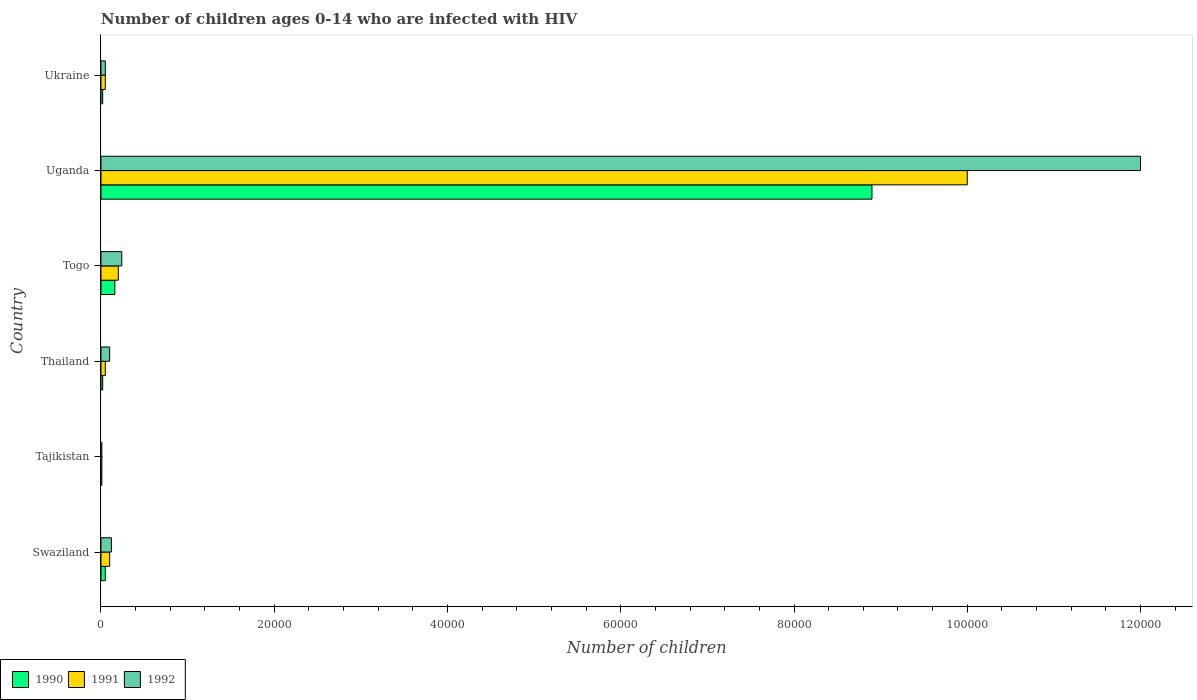How many different coloured bars are there?
Keep it short and to the point. 3. How many bars are there on the 1st tick from the top?
Provide a short and direct response. 3. How many bars are there on the 2nd tick from the bottom?
Provide a succinct answer. 3. What is the label of the 4th group of bars from the top?
Your answer should be compact. Thailand. What is the number of HIV infected children in 1991 in Thailand?
Keep it short and to the point. 500. Across all countries, what is the maximum number of HIV infected children in 1992?
Keep it short and to the point. 1.20e+05. Across all countries, what is the minimum number of HIV infected children in 1991?
Offer a very short reply. 100. In which country was the number of HIV infected children in 1990 maximum?
Make the answer very short. Uganda. In which country was the number of HIV infected children in 1991 minimum?
Provide a short and direct response. Tajikistan. What is the total number of HIV infected children in 1990 in the graph?
Your answer should be very brief. 9.16e+04. What is the difference between the number of HIV infected children in 1991 in Tajikistan and that in Thailand?
Your answer should be compact. -400. What is the difference between the number of HIV infected children in 1990 in Togo and the number of HIV infected children in 1991 in Swaziland?
Ensure brevity in your answer.  600. What is the average number of HIV infected children in 1991 per country?
Your answer should be compact. 1.74e+04. What is the difference between the number of HIV infected children in 1992 and number of HIV infected children in 1991 in Togo?
Provide a succinct answer. 400. In how many countries, is the number of HIV infected children in 1991 greater than 20000 ?
Offer a very short reply. 1. Is the number of HIV infected children in 1991 in Tajikistan less than that in Ukraine?
Provide a succinct answer. Yes. What is the difference between the highest and the second highest number of HIV infected children in 1992?
Offer a very short reply. 1.18e+05. What is the difference between the highest and the lowest number of HIV infected children in 1992?
Offer a very short reply. 1.20e+05. What does the 3rd bar from the top in Tajikistan represents?
Offer a very short reply. 1990. What does the 3rd bar from the bottom in Togo represents?
Your answer should be compact. 1992. How many bars are there?
Offer a terse response. 18. Are all the bars in the graph horizontal?
Offer a terse response. Yes. Does the graph contain any zero values?
Provide a succinct answer. No. Where does the legend appear in the graph?
Your answer should be very brief. Bottom left. How are the legend labels stacked?
Your response must be concise. Horizontal. What is the title of the graph?
Provide a succinct answer. Number of children ages 0-14 who are infected with HIV. What is the label or title of the X-axis?
Make the answer very short. Number of children. What is the Number of children of 1991 in Swaziland?
Your answer should be compact. 1000. What is the Number of children in 1992 in Swaziland?
Provide a succinct answer. 1200. What is the Number of children in 1990 in Tajikistan?
Your answer should be compact. 100. What is the Number of children of 1991 in Tajikistan?
Provide a succinct answer. 100. What is the Number of children of 1992 in Tajikistan?
Ensure brevity in your answer.  100. What is the Number of children of 1990 in Thailand?
Provide a short and direct response. 200. What is the Number of children of 1992 in Thailand?
Offer a very short reply. 1000. What is the Number of children of 1990 in Togo?
Your answer should be very brief. 1600. What is the Number of children of 1992 in Togo?
Make the answer very short. 2400. What is the Number of children of 1990 in Uganda?
Provide a succinct answer. 8.90e+04. What is the Number of children of 1990 in Ukraine?
Your answer should be very brief. 200. Across all countries, what is the maximum Number of children of 1990?
Your response must be concise. 8.90e+04. Across all countries, what is the minimum Number of children in 1990?
Offer a terse response. 100. Across all countries, what is the minimum Number of children of 1991?
Keep it short and to the point. 100. Across all countries, what is the minimum Number of children of 1992?
Ensure brevity in your answer.  100. What is the total Number of children in 1990 in the graph?
Ensure brevity in your answer.  9.16e+04. What is the total Number of children in 1991 in the graph?
Your answer should be compact. 1.04e+05. What is the total Number of children in 1992 in the graph?
Offer a very short reply. 1.25e+05. What is the difference between the Number of children of 1991 in Swaziland and that in Tajikistan?
Make the answer very short. 900. What is the difference between the Number of children of 1992 in Swaziland and that in Tajikistan?
Provide a short and direct response. 1100. What is the difference between the Number of children of 1990 in Swaziland and that in Thailand?
Offer a very short reply. 300. What is the difference between the Number of children in 1990 in Swaziland and that in Togo?
Provide a succinct answer. -1100. What is the difference between the Number of children of 1991 in Swaziland and that in Togo?
Ensure brevity in your answer.  -1000. What is the difference between the Number of children of 1992 in Swaziland and that in Togo?
Your answer should be very brief. -1200. What is the difference between the Number of children of 1990 in Swaziland and that in Uganda?
Ensure brevity in your answer.  -8.85e+04. What is the difference between the Number of children of 1991 in Swaziland and that in Uganda?
Offer a terse response. -9.90e+04. What is the difference between the Number of children of 1992 in Swaziland and that in Uganda?
Give a very brief answer. -1.19e+05. What is the difference between the Number of children in 1990 in Swaziland and that in Ukraine?
Your answer should be very brief. 300. What is the difference between the Number of children of 1991 in Swaziland and that in Ukraine?
Provide a succinct answer. 500. What is the difference between the Number of children of 1992 in Swaziland and that in Ukraine?
Provide a succinct answer. 700. What is the difference between the Number of children in 1990 in Tajikistan and that in Thailand?
Your answer should be compact. -100. What is the difference between the Number of children in 1991 in Tajikistan and that in Thailand?
Offer a very short reply. -400. What is the difference between the Number of children of 1992 in Tajikistan and that in Thailand?
Make the answer very short. -900. What is the difference between the Number of children of 1990 in Tajikistan and that in Togo?
Provide a short and direct response. -1500. What is the difference between the Number of children in 1991 in Tajikistan and that in Togo?
Provide a succinct answer. -1900. What is the difference between the Number of children in 1992 in Tajikistan and that in Togo?
Provide a short and direct response. -2300. What is the difference between the Number of children in 1990 in Tajikistan and that in Uganda?
Keep it short and to the point. -8.89e+04. What is the difference between the Number of children in 1991 in Tajikistan and that in Uganda?
Keep it short and to the point. -9.99e+04. What is the difference between the Number of children in 1992 in Tajikistan and that in Uganda?
Your response must be concise. -1.20e+05. What is the difference between the Number of children of 1990 in Tajikistan and that in Ukraine?
Your answer should be compact. -100. What is the difference between the Number of children in 1991 in Tajikistan and that in Ukraine?
Your response must be concise. -400. What is the difference between the Number of children of 1992 in Tajikistan and that in Ukraine?
Offer a terse response. -400. What is the difference between the Number of children in 1990 in Thailand and that in Togo?
Your response must be concise. -1400. What is the difference between the Number of children in 1991 in Thailand and that in Togo?
Offer a very short reply. -1500. What is the difference between the Number of children in 1992 in Thailand and that in Togo?
Ensure brevity in your answer.  -1400. What is the difference between the Number of children of 1990 in Thailand and that in Uganda?
Ensure brevity in your answer.  -8.88e+04. What is the difference between the Number of children in 1991 in Thailand and that in Uganda?
Make the answer very short. -9.95e+04. What is the difference between the Number of children in 1992 in Thailand and that in Uganda?
Your response must be concise. -1.19e+05. What is the difference between the Number of children in 1992 in Thailand and that in Ukraine?
Keep it short and to the point. 500. What is the difference between the Number of children in 1990 in Togo and that in Uganda?
Provide a succinct answer. -8.74e+04. What is the difference between the Number of children in 1991 in Togo and that in Uganda?
Keep it short and to the point. -9.80e+04. What is the difference between the Number of children in 1992 in Togo and that in Uganda?
Ensure brevity in your answer.  -1.18e+05. What is the difference between the Number of children in 1990 in Togo and that in Ukraine?
Offer a very short reply. 1400. What is the difference between the Number of children in 1991 in Togo and that in Ukraine?
Your response must be concise. 1500. What is the difference between the Number of children in 1992 in Togo and that in Ukraine?
Provide a succinct answer. 1900. What is the difference between the Number of children of 1990 in Uganda and that in Ukraine?
Give a very brief answer. 8.88e+04. What is the difference between the Number of children in 1991 in Uganda and that in Ukraine?
Your answer should be very brief. 9.95e+04. What is the difference between the Number of children in 1992 in Uganda and that in Ukraine?
Make the answer very short. 1.20e+05. What is the difference between the Number of children of 1991 in Swaziland and the Number of children of 1992 in Tajikistan?
Ensure brevity in your answer.  900. What is the difference between the Number of children of 1990 in Swaziland and the Number of children of 1991 in Thailand?
Offer a very short reply. 0. What is the difference between the Number of children of 1990 in Swaziland and the Number of children of 1992 in Thailand?
Provide a short and direct response. -500. What is the difference between the Number of children in 1991 in Swaziland and the Number of children in 1992 in Thailand?
Ensure brevity in your answer.  0. What is the difference between the Number of children in 1990 in Swaziland and the Number of children in 1991 in Togo?
Provide a succinct answer. -1500. What is the difference between the Number of children of 1990 in Swaziland and the Number of children of 1992 in Togo?
Keep it short and to the point. -1900. What is the difference between the Number of children of 1991 in Swaziland and the Number of children of 1992 in Togo?
Your answer should be compact. -1400. What is the difference between the Number of children in 1990 in Swaziland and the Number of children in 1991 in Uganda?
Give a very brief answer. -9.95e+04. What is the difference between the Number of children of 1990 in Swaziland and the Number of children of 1992 in Uganda?
Make the answer very short. -1.20e+05. What is the difference between the Number of children in 1991 in Swaziland and the Number of children in 1992 in Uganda?
Offer a very short reply. -1.19e+05. What is the difference between the Number of children of 1991 in Swaziland and the Number of children of 1992 in Ukraine?
Your answer should be very brief. 500. What is the difference between the Number of children in 1990 in Tajikistan and the Number of children in 1991 in Thailand?
Your answer should be very brief. -400. What is the difference between the Number of children in 1990 in Tajikistan and the Number of children in 1992 in Thailand?
Keep it short and to the point. -900. What is the difference between the Number of children in 1991 in Tajikistan and the Number of children in 1992 in Thailand?
Offer a very short reply. -900. What is the difference between the Number of children of 1990 in Tajikistan and the Number of children of 1991 in Togo?
Your answer should be compact. -1900. What is the difference between the Number of children of 1990 in Tajikistan and the Number of children of 1992 in Togo?
Ensure brevity in your answer.  -2300. What is the difference between the Number of children in 1991 in Tajikistan and the Number of children in 1992 in Togo?
Offer a terse response. -2300. What is the difference between the Number of children of 1990 in Tajikistan and the Number of children of 1991 in Uganda?
Your response must be concise. -9.99e+04. What is the difference between the Number of children of 1990 in Tajikistan and the Number of children of 1992 in Uganda?
Your answer should be compact. -1.20e+05. What is the difference between the Number of children of 1991 in Tajikistan and the Number of children of 1992 in Uganda?
Provide a short and direct response. -1.20e+05. What is the difference between the Number of children of 1990 in Tajikistan and the Number of children of 1991 in Ukraine?
Your answer should be compact. -400. What is the difference between the Number of children of 1990 in Tajikistan and the Number of children of 1992 in Ukraine?
Your response must be concise. -400. What is the difference between the Number of children in 1991 in Tajikistan and the Number of children in 1992 in Ukraine?
Provide a short and direct response. -400. What is the difference between the Number of children of 1990 in Thailand and the Number of children of 1991 in Togo?
Provide a succinct answer. -1800. What is the difference between the Number of children in 1990 in Thailand and the Number of children in 1992 in Togo?
Offer a terse response. -2200. What is the difference between the Number of children of 1991 in Thailand and the Number of children of 1992 in Togo?
Ensure brevity in your answer.  -1900. What is the difference between the Number of children of 1990 in Thailand and the Number of children of 1991 in Uganda?
Offer a very short reply. -9.98e+04. What is the difference between the Number of children in 1990 in Thailand and the Number of children in 1992 in Uganda?
Your answer should be compact. -1.20e+05. What is the difference between the Number of children in 1991 in Thailand and the Number of children in 1992 in Uganda?
Your answer should be compact. -1.20e+05. What is the difference between the Number of children in 1990 in Thailand and the Number of children in 1991 in Ukraine?
Give a very brief answer. -300. What is the difference between the Number of children of 1990 in Thailand and the Number of children of 1992 in Ukraine?
Your response must be concise. -300. What is the difference between the Number of children of 1990 in Togo and the Number of children of 1991 in Uganda?
Ensure brevity in your answer.  -9.84e+04. What is the difference between the Number of children of 1990 in Togo and the Number of children of 1992 in Uganda?
Provide a succinct answer. -1.18e+05. What is the difference between the Number of children in 1991 in Togo and the Number of children in 1992 in Uganda?
Give a very brief answer. -1.18e+05. What is the difference between the Number of children in 1990 in Togo and the Number of children in 1991 in Ukraine?
Offer a terse response. 1100. What is the difference between the Number of children of 1990 in Togo and the Number of children of 1992 in Ukraine?
Your answer should be compact. 1100. What is the difference between the Number of children of 1991 in Togo and the Number of children of 1992 in Ukraine?
Ensure brevity in your answer.  1500. What is the difference between the Number of children of 1990 in Uganda and the Number of children of 1991 in Ukraine?
Provide a succinct answer. 8.85e+04. What is the difference between the Number of children in 1990 in Uganda and the Number of children in 1992 in Ukraine?
Provide a short and direct response. 8.85e+04. What is the difference between the Number of children of 1991 in Uganda and the Number of children of 1992 in Ukraine?
Provide a succinct answer. 9.95e+04. What is the average Number of children in 1990 per country?
Your answer should be very brief. 1.53e+04. What is the average Number of children in 1991 per country?
Your response must be concise. 1.74e+04. What is the average Number of children in 1992 per country?
Provide a short and direct response. 2.09e+04. What is the difference between the Number of children of 1990 and Number of children of 1991 in Swaziland?
Offer a very short reply. -500. What is the difference between the Number of children of 1990 and Number of children of 1992 in Swaziland?
Ensure brevity in your answer.  -700. What is the difference between the Number of children of 1991 and Number of children of 1992 in Swaziland?
Your answer should be very brief. -200. What is the difference between the Number of children in 1990 and Number of children in 1991 in Thailand?
Provide a short and direct response. -300. What is the difference between the Number of children of 1990 and Number of children of 1992 in Thailand?
Make the answer very short. -800. What is the difference between the Number of children of 1991 and Number of children of 1992 in Thailand?
Provide a succinct answer. -500. What is the difference between the Number of children of 1990 and Number of children of 1991 in Togo?
Give a very brief answer. -400. What is the difference between the Number of children in 1990 and Number of children in 1992 in Togo?
Provide a short and direct response. -800. What is the difference between the Number of children in 1991 and Number of children in 1992 in Togo?
Provide a succinct answer. -400. What is the difference between the Number of children of 1990 and Number of children of 1991 in Uganda?
Your response must be concise. -1.10e+04. What is the difference between the Number of children in 1990 and Number of children in 1992 in Uganda?
Your response must be concise. -3.10e+04. What is the difference between the Number of children in 1990 and Number of children in 1991 in Ukraine?
Your answer should be compact. -300. What is the difference between the Number of children of 1990 and Number of children of 1992 in Ukraine?
Your answer should be compact. -300. What is the ratio of the Number of children in 1990 in Swaziland to that in Tajikistan?
Your answer should be very brief. 5. What is the ratio of the Number of children in 1991 in Swaziland to that in Tajikistan?
Your answer should be compact. 10. What is the ratio of the Number of children in 1991 in Swaziland to that in Thailand?
Your answer should be compact. 2. What is the ratio of the Number of children of 1990 in Swaziland to that in Togo?
Your response must be concise. 0.31. What is the ratio of the Number of children in 1991 in Swaziland to that in Togo?
Your response must be concise. 0.5. What is the ratio of the Number of children in 1990 in Swaziland to that in Uganda?
Your response must be concise. 0.01. What is the ratio of the Number of children in 1991 in Swaziland to that in Uganda?
Ensure brevity in your answer.  0.01. What is the ratio of the Number of children of 1990 in Swaziland to that in Ukraine?
Give a very brief answer. 2.5. What is the ratio of the Number of children of 1991 in Swaziland to that in Ukraine?
Keep it short and to the point. 2. What is the ratio of the Number of children of 1992 in Tajikistan to that in Thailand?
Your answer should be compact. 0.1. What is the ratio of the Number of children of 1990 in Tajikistan to that in Togo?
Provide a succinct answer. 0.06. What is the ratio of the Number of children in 1991 in Tajikistan to that in Togo?
Provide a short and direct response. 0.05. What is the ratio of the Number of children of 1992 in Tajikistan to that in Togo?
Your answer should be compact. 0.04. What is the ratio of the Number of children of 1990 in Tajikistan to that in Uganda?
Give a very brief answer. 0. What is the ratio of the Number of children in 1992 in Tajikistan to that in Uganda?
Your response must be concise. 0. What is the ratio of the Number of children in 1990 in Tajikistan to that in Ukraine?
Your answer should be compact. 0.5. What is the ratio of the Number of children of 1991 in Thailand to that in Togo?
Ensure brevity in your answer.  0.25. What is the ratio of the Number of children of 1992 in Thailand to that in Togo?
Offer a terse response. 0.42. What is the ratio of the Number of children in 1990 in Thailand to that in Uganda?
Offer a terse response. 0. What is the ratio of the Number of children of 1991 in Thailand to that in Uganda?
Ensure brevity in your answer.  0.01. What is the ratio of the Number of children of 1992 in Thailand to that in Uganda?
Your answer should be very brief. 0.01. What is the ratio of the Number of children of 1991 in Thailand to that in Ukraine?
Offer a very short reply. 1. What is the ratio of the Number of children in 1992 in Thailand to that in Ukraine?
Keep it short and to the point. 2. What is the ratio of the Number of children in 1990 in Togo to that in Uganda?
Provide a short and direct response. 0.02. What is the ratio of the Number of children of 1991 in Togo to that in Uganda?
Ensure brevity in your answer.  0.02. What is the ratio of the Number of children of 1992 in Togo to that in Uganda?
Keep it short and to the point. 0.02. What is the ratio of the Number of children of 1990 in Togo to that in Ukraine?
Ensure brevity in your answer.  8. What is the ratio of the Number of children of 1991 in Togo to that in Ukraine?
Offer a very short reply. 4. What is the ratio of the Number of children of 1992 in Togo to that in Ukraine?
Offer a terse response. 4.8. What is the ratio of the Number of children of 1990 in Uganda to that in Ukraine?
Offer a very short reply. 445. What is the ratio of the Number of children in 1992 in Uganda to that in Ukraine?
Give a very brief answer. 240. What is the difference between the highest and the second highest Number of children in 1990?
Make the answer very short. 8.74e+04. What is the difference between the highest and the second highest Number of children of 1991?
Make the answer very short. 9.80e+04. What is the difference between the highest and the second highest Number of children in 1992?
Provide a succinct answer. 1.18e+05. What is the difference between the highest and the lowest Number of children of 1990?
Provide a succinct answer. 8.89e+04. What is the difference between the highest and the lowest Number of children of 1991?
Give a very brief answer. 9.99e+04. What is the difference between the highest and the lowest Number of children in 1992?
Your answer should be compact. 1.20e+05. 